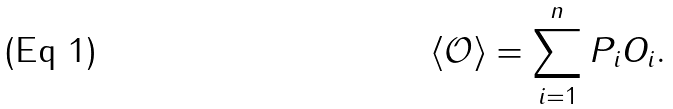Convert formula to latex. <formula><loc_0><loc_0><loc_500><loc_500>\left \langle \mathcal { O } \right \rangle = \sum _ { i = 1 } ^ { n } P _ { i } O _ { i } .</formula> 